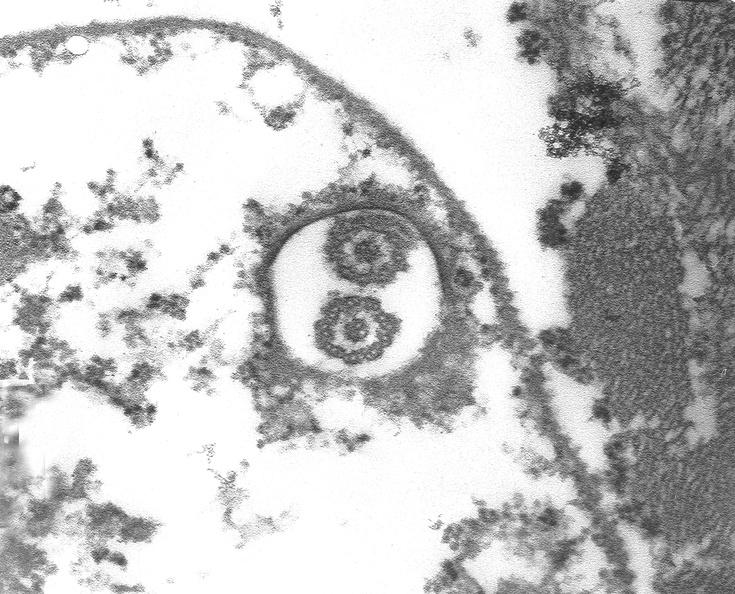s cardiovascular present?
Answer the question using a single word or phrase. Yes 